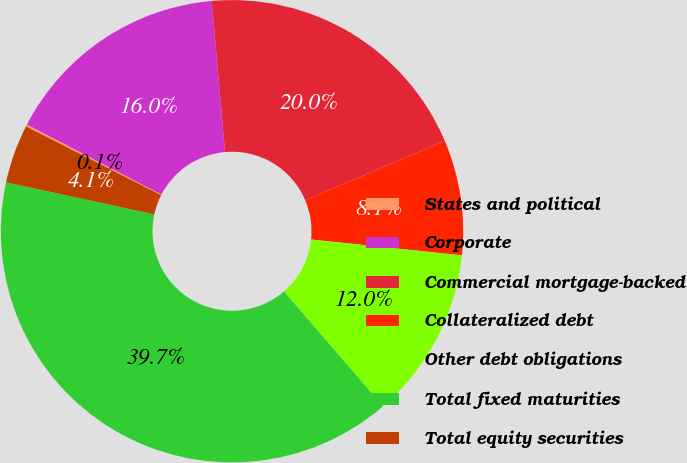Convert chart to OTSL. <chart><loc_0><loc_0><loc_500><loc_500><pie_chart><fcel>States and political<fcel>Corporate<fcel>Commercial mortgage-backed<fcel>Collateralized debt<fcel>Other debt obligations<fcel>Total fixed maturities<fcel>Total equity securities<nl><fcel>0.14%<fcel>15.97%<fcel>20.0%<fcel>8.06%<fcel>12.01%<fcel>39.72%<fcel>4.1%<nl></chart> 